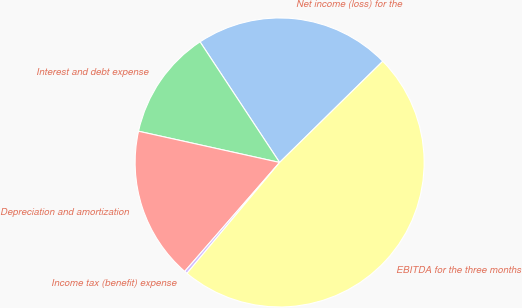<chart> <loc_0><loc_0><loc_500><loc_500><pie_chart><fcel>Net income (loss) for the<fcel>Interest and debt expense<fcel>Depreciation and amortization<fcel>Income tax (benefit) expense<fcel>EBITDA for the three months<nl><fcel>21.93%<fcel>12.25%<fcel>17.06%<fcel>0.33%<fcel>48.42%<nl></chart> 